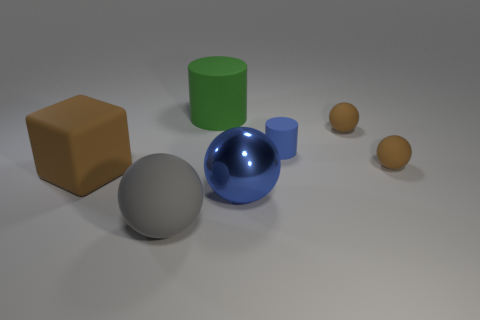Add 2 big green rubber objects. How many objects exist? 9 Subtract all balls. How many objects are left? 3 Add 1 cyan shiny spheres. How many cyan shiny spheres exist? 1 Subtract 0 green cubes. How many objects are left? 7 Subtract all small brown rubber objects. Subtract all big blocks. How many objects are left? 4 Add 1 gray matte things. How many gray matte things are left? 2 